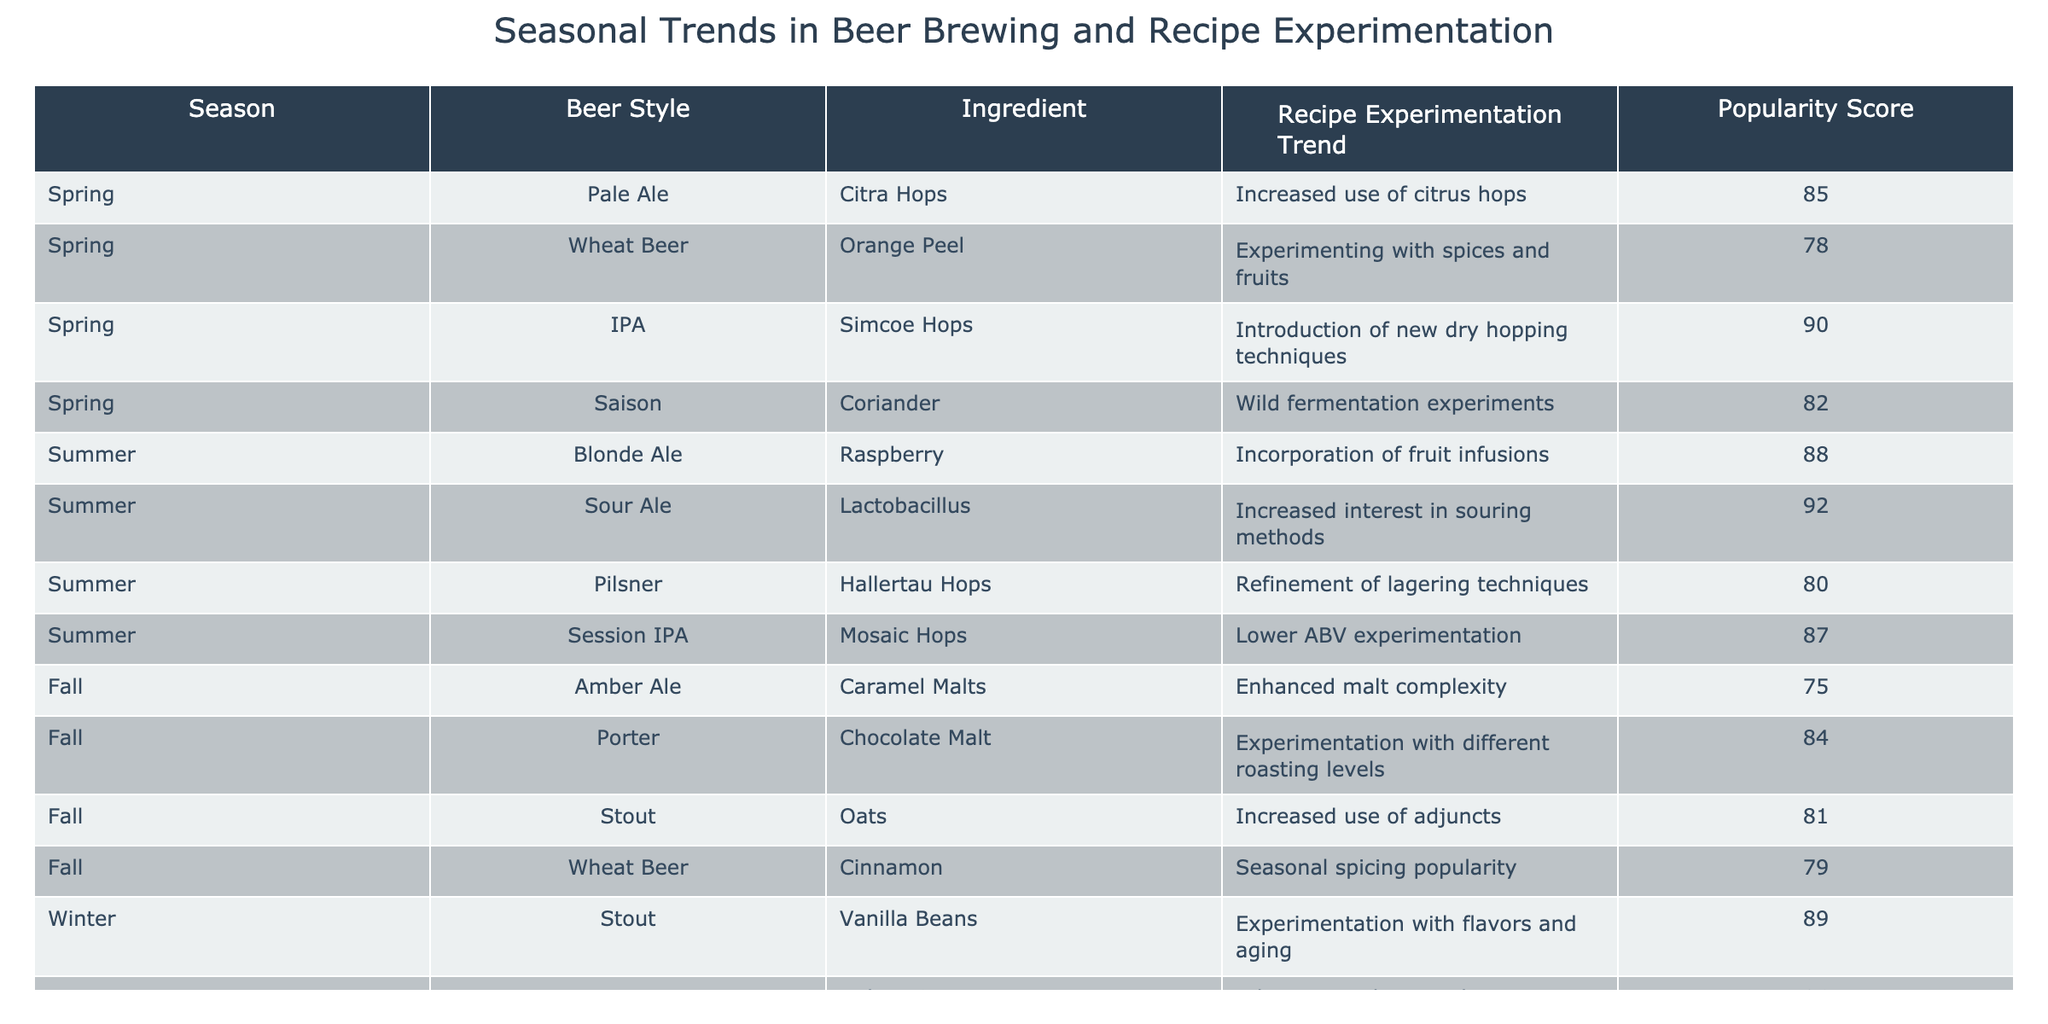What's the most popular beer style in Spring? Looking at the popularity scores for Spring, the beer styles are Pale Ale (85), Wheat Beer (78), IPA (90), and Saison (82). The IPA has the highest score, with a score of 90.
Answer: IPA Which ingredient had the highest popularity score in Winter? In Winter, the ingredients and their popularity scores are: Stout with Vanilla Beans (89), IPA with Nelson Sauvin (86), and Old Ale with Oak Chips (93). The Old Ale with Oak Chips has the highest score at 93.
Answer: Oak Chips What is the average popularity score for Summer beer styles? The popularity scores for Summer styles are: Blonde Ale (88), Sour Ale (92), Pilsner (80), and Session IPA (87). Adding these gives 88 + 92 + 80 + 87 = 347, and there are 4 styles, so the average is 347 / 4 = 86.75.
Answer: 86.75 Is there any beer style in Fall that uses fruit as an ingredient? The Fall beer styles listed are Amber Ale, Porter, Stout, and Wheat Beer, none of which include fruit as an ingredient. Therefore, the answer is no.
Answer: No Which season has the highest average popularity score across all beer styles? We calculate the average popularity for each season: Spring (85 + 78 + 90 + 82 = 335, average = 335/4 = 83.75), Summer (88 + 92 + 80 + 87 = 347, average = 347/4 = 86.75), Fall (75 + 84 + 81 + 79 = 319, average = 319/4 = 79.75), and Winter (89 + 86 + 93 = 268, average = 268/3 = 89.33). Winter has the highest average at 89.33.
Answer: Winter What trend is common across all seasonal beer styles in the table? The table indicates that various ingredients and techniques are being experimental across all seasons, but there is a clear focus on the experimentation with ingredients like hops and adjuncts in several styles. This experimentation trend is common.
Answer: Experimentation with ingredients and techniques Which beer style in Summer has the lowest popularity score? Analyzing the Summer beer styles: Blonde Ale (88), Sour Ale (92), Pilsner (80), and Session IPA (87), the Pilsner has the lowest score at 80.
Answer: Pilsner Which ingredient trend is noted most for Spring season? In Spring, the ingredients and corresponding trends indicate an increase in the use of citrus hops, particularly Citra Hops for Pale Ale, which is noted as an increased trend.
Answer: Increased use of citrus hops 